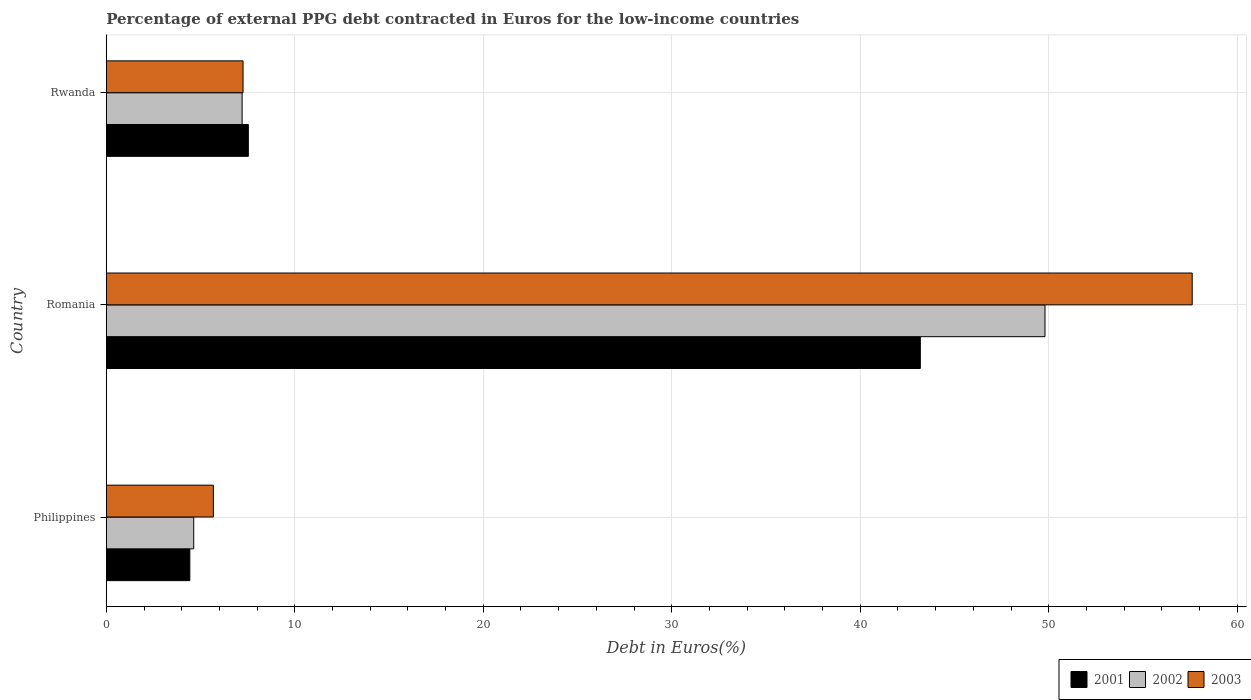How many different coloured bars are there?
Offer a very short reply. 3. Are the number of bars per tick equal to the number of legend labels?
Your answer should be very brief. Yes. How many bars are there on the 2nd tick from the top?
Offer a terse response. 3. What is the percentage of external PPG debt contracted in Euros in 2001 in Rwanda?
Give a very brief answer. 7.53. Across all countries, what is the maximum percentage of external PPG debt contracted in Euros in 2001?
Give a very brief answer. 43.19. Across all countries, what is the minimum percentage of external PPG debt contracted in Euros in 2002?
Your answer should be compact. 4.64. In which country was the percentage of external PPG debt contracted in Euros in 2002 maximum?
Offer a terse response. Romania. In which country was the percentage of external PPG debt contracted in Euros in 2003 minimum?
Your response must be concise. Philippines. What is the total percentage of external PPG debt contracted in Euros in 2002 in the graph?
Make the answer very short. 61.64. What is the difference between the percentage of external PPG debt contracted in Euros in 2002 in Philippines and that in Rwanda?
Keep it short and to the point. -2.57. What is the difference between the percentage of external PPG debt contracted in Euros in 2002 in Romania and the percentage of external PPG debt contracted in Euros in 2003 in Rwanda?
Give a very brief answer. 42.55. What is the average percentage of external PPG debt contracted in Euros in 2003 per country?
Keep it short and to the point. 23.52. What is the difference between the percentage of external PPG debt contracted in Euros in 2002 and percentage of external PPG debt contracted in Euros in 2001 in Romania?
Give a very brief answer. 6.61. In how many countries, is the percentage of external PPG debt contracted in Euros in 2001 greater than 58 %?
Your response must be concise. 0. What is the ratio of the percentage of external PPG debt contracted in Euros in 2001 in Philippines to that in Rwanda?
Give a very brief answer. 0.59. Is the percentage of external PPG debt contracted in Euros in 2002 in Romania less than that in Rwanda?
Offer a very short reply. No. What is the difference between the highest and the second highest percentage of external PPG debt contracted in Euros in 2002?
Keep it short and to the point. 42.6. What is the difference between the highest and the lowest percentage of external PPG debt contracted in Euros in 2001?
Offer a very short reply. 38.76. Is the sum of the percentage of external PPG debt contracted in Euros in 2003 in Philippines and Romania greater than the maximum percentage of external PPG debt contracted in Euros in 2002 across all countries?
Your answer should be compact. Yes. How many bars are there?
Your answer should be very brief. 9. How many countries are there in the graph?
Keep it short and to the point. 3. What is the difference between two consecutive major ticks on the X-axis?
Make the answer very short. 10. How many legend labels are there?
Ensure brevity in your answer.  3. How are the legend labels stacked?
Your answer should be compact. Horizontal. What is the title of the graph?
Provide a short and direct response. Percentage of external PPG debt contracted in Euros for the low-income countries. Does "1984" appear as one of the legend labels in the graph?
Offer a very short reply. No. What is the label or title of the X-axis?
Make the answer very short. Debt in Euros(%). What is the label or title of the Y-axis?
Provide a short and direct response. Country. What is the Debt in Euros(%) in 2001 in Philippines?
Your response must be concise. 4.43. What is the Debt in Euros(%) in 2002 in Philippines?
Provide a short and direct response. 4.64. What is the Debt in Euros(%) in 2003 in Philippines?
Your answer should be compact. 5.68. What is the Debt in Euros(%) in 2001 in Romania?
Your answer should be compact. 43.19. What is the Debt in Euros(%) of 2002 in Romania?
Your answer should be compact. 49.8. What is the Debt in Euros(%) of 2003 in Romania?
Offer a terse response. 57.61. What is the Debt in Euros(%) of 2001 in Rwanda?
Keep it short and to the point. 7.53. What is the Debt in Euros(%) in 2002 in Rwanda?
Your answer should be compact. 7.2. What is the Debt in Euros(%) of 2003 in Rwanda?
Offer a terse response. 7.25. Across all countries, what is the maximum Debt in Euros(%) of 2001?
Ensure brevity in your answer.  43.19. Across all countries, what is the maximum Debt in Euros(%) in 2002?
Offer a terse response. 49.8. Across all countries, what is the maximum Debt in Euros(%) in 2003?
Your answer should be very brief. 57.61. Across all countries, what is the minimum Debt in Euros(%) in 2001?
Offer a very short reply. 4.43. Across all countries, what is the minimum Debt in Euros(%) in 2002?
Give a very brief answer. 4.64. Across all countries, what is the minimum Debt in Euros(%) in 2003?
Your answer should be compact. 5.68. What is the total Debt in Euros(%) in 2001 in the graph?
Ensure brevity in your answer.  55.15. What is the total Debt in Euros(%) in 2002 in the graph?
Make the answer very short. 61.64. What is the total Debt in Euros(%) in 2003 in the graph?
Ensure brevity in your answer.  70.55. What is the difference between the Debt in Euros(%) of 2001 in Philippines and that in Romania?
Offer a terse response. -38.76. What is the difference between the Debt in Euros(%) of 2002 in Philippines and that in Romania?
Make the answer very short. -45.17. What is the difference between the Debt in Euros(%) of 2003 in Philippines and that in Romania?
Keep it short and to the point. -51.93. What is the difference between the Debt in Euros(%) in 2001 in Philippines and that in Rwanda?
Ensure brevity in your answer.  -3.1. What is the difference between the Debt in Euros(%) of 2002 in Philippines and that in Rwanda?
Your answer should be compact. -2.57. What is the difference between the Debt in Euros(%) in 2003 in Philippines and that in Rwanda?
Your response must be concise. -1.57. What is the difference between the Debt in Euros(%) of 2001 in Romania and that in Rwanda?
Make the answer very short. 35.65. What is the difference between the Debt in Euros(%) of 2002 in Romania and that in Rwanda?
Your response must be concise. 42.6. What is the difference between the Debt in Euros(%) in 2003 in Romania and that in Rwanda?
Ensure brevity in your answer.  50.36. What is the difference between the Debt in Euros(%) of 2001 in Philippines and the Debt in Euros(%) of 2002 in Romania?
Keep it short and to the point. -45.37. What is the difference between the Debt in Euros(%) of 2001 in Philippines and the Debt in Euros(%) of 2003 in Romania?
Provide a short and direct response. -53.18. What is the difference between the Debt in Euros(%) in 2002 in Philippines and the Debt in Euros(%) in 2003 in Romania?
Your answer should be compact. -52.98. What is the difference between the Debt in Euros(%) of 2001 in Philippines and the Debt in Euros(%) of 2002 in Rwanda?
Ensure brevity in your answer.  -2.77. What is the difference between the Debt in Euros(%) in 2001 in Philippines and the Debt in Euros(%) in 2003 in Rwanda?
Offer a terse response. -2.82. What is the difference between the Debt in Euros(%) of 2002 in Philippines and the Debt in Euros(%) of 2003 in Rwanda?
Your answer should be compact. -2.62. What is the difference between the Debt in Euros(%) of 2001 in Romania and the Debt in Euros(%) of 2002 in Rwanda?
Your answer should be compact. 35.98. What is the difference between the Debt in Euros(%) in 2001 in Romania and the Debt in Euros(%) in 2003 in Rwanda?
Your answer should be very brief. 35.93. What is the difference between the Debt in Euros(%) in 2002 in Romania and the Debt in Euros(%) in 2003 in Rwanda?
Make the answer very short. 42.55. What is the average Debt in Euros(%) in 2001 per country?
Provide a succinct answer. 18.38. What is the average Debt in Euros(%) of 2002 per country?
Keep it short and to the point. 20.55. What is the average Debt in Euros(%) in 2003 per country?
Ensure brevity in your answer.  23.52. What is the difference between the Debt in Euros(%) in 2001 and Debt in Euros(%) in 2002 in Philippines?
Ensure brevity in your answer.  -0.21. What is the difference between the Debt in Euros(%) in 2001 and Debt in Euros(%) in 2003 in Philippines?
Provide a succinct answer. -1.25. What is the difference between the Debt in Euros(%) in 2002 and Debt in Euros(%) in 2003 in Philippines?
Your answer should be compact. -1.04. What is the difference between the Debt in Euros(%) in 2001 and Debt in Euros(%) in 2002 in Romania?
Your answer should be very brief. -6.61. What is the difference between the Debt in Euros(%) in 2001 and Debt in Euros(%) in 2003 in Romania?
Your response must be concise. -14.43. What is the difference between the Debt in Euros(%) in 2002 and Debt in Euros(%) in 2003 in Romania?
Make the answer very short. -7.81. What is the difference between the Debt in Euros(%) of 2001 and Debt in Euros(%) of 2002 in Rwanda?
Your answer should be compact. 0.33. What is the difference between the Debt in Euros(%) of 2001 and Debt in Euros(%) of 2003 in Rwanda?
Your answer should be compact. 0.28. What is the difference between the Debt in Euros(%) in 2002 and Debt in Euros(%) in 2003 in Rwanda?
Provide a short and direct response. -0.05. What is the ratio of the Debt in Euros(%) of 2001 in Philippines to that in Romania?
Give a very brief answer. 0.1. What is the ratio of the Debt in Euros(%) in 2002 in Philippines to that in Romania?
Your answer should be very brief. 0.09. What is the ratio of the Debt in Euros(%) of 2003 in Philippines to that in Romania?
Make the answer very short. 0.1. What is the ratio of the Debt in Euros(%) of 2001 in Philippines to that in Rwanda?
Offer a terse response. 0.59. What is the ratio of the Debt in Euros(%) in 2002 in Philippines to that in Rwanda?
Offer a terse response. 0.64. What is the ratio of the Debt in Euros(%) in 2003 in Philippines to that in Rwanda?
Give a very brief answer. 0.78. What is the ratio of the Debt in Euros(%) in 2001 in Romania to that in Rwanda?
Offer a very short reply. 5.73. What is the ratio of the Debt in Euros(%) in 2002 in Romania to that in Rwanda?
Make the answer very short. 6.91. What is the ratio of the Debt in Euros(%) of 2003 in Romania to that in Rwanda?
Keep it short and to the point. 7.94. What is the difference between the highest and the second highest Debt in Euros(%) in 2001?
Your answer should be very brief. 35.65. What is the difference between the highest and the second highest Debt in Euros(%) of 2002?
Make the answer very short. 42.6. What is the difference between the highest and the second highest Debt in Euros(%) of 2003?
Provide a short and direct response. 50.36. What is the difference between the highest and the lowest Debt in Euros(%) in 2001?
Make the answer very short. 38.76. What is the difference between the highest and the lowest Debt in Euros(%) of 2002?
Ensure brevity in your answer.  45.17. What is the difference between the highest and the lowest Debt in Euros(%) of 2003?
Provide a succinct answer. 51.93. 